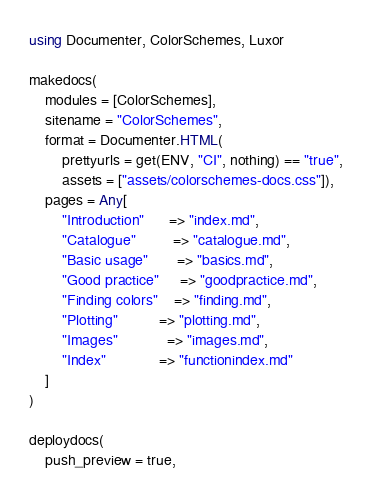<code> <loc_0><loc_0><loc_500><loc_500><_Julia_>using Documenter, ColorSchemes, Luxor

makedocs(
    modules = [ColorSchemes],
    sitename = "ColorSchemes",
    format = Documenter.HTML(
        prettyurls = get(ENV, "CI", nothing) == "true",
        assets = ["assets/colorschemes-docs.css"]),
    pages = Any[
        "Introduction"      => "index.md",
        "Catalogue"         => "catalogue.md",
        "Basic usage"       => "basics.md",
        "Good practice"     => "goodpractice.md",
        "Finding colors"    => "finding.md",
        "Plotting"          => "plotting.md",
        "Images"            => "images.md",
        "Index"             => "functionindex.md"
    ]
)

deploydocs(
    push_preview = true,</code> 